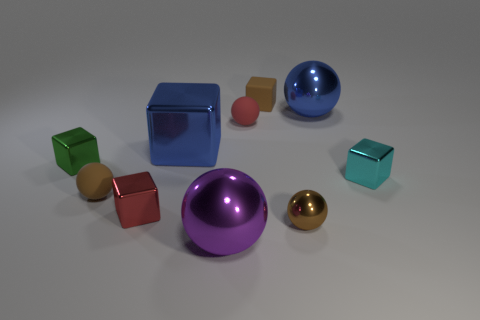Subtract all red spheres. How many spheres are left? 4 Subtract 2 balls. How many balls are left? 3 Subtract all tiny rubber blocks. How many blocks are left? 4 Subtract all gray blocks. Subtract all red cylinders. How many blocks are left? 5 Subtract all large metal balls. Subtract all small cyan things. How many objects are left? 7 Add 3 large things. How many large things are left? 6 Add 6 small red rubber things. How many small red rubber things exist? 7 Subtract 0 yellow cylinders. How many objects are left? 10 